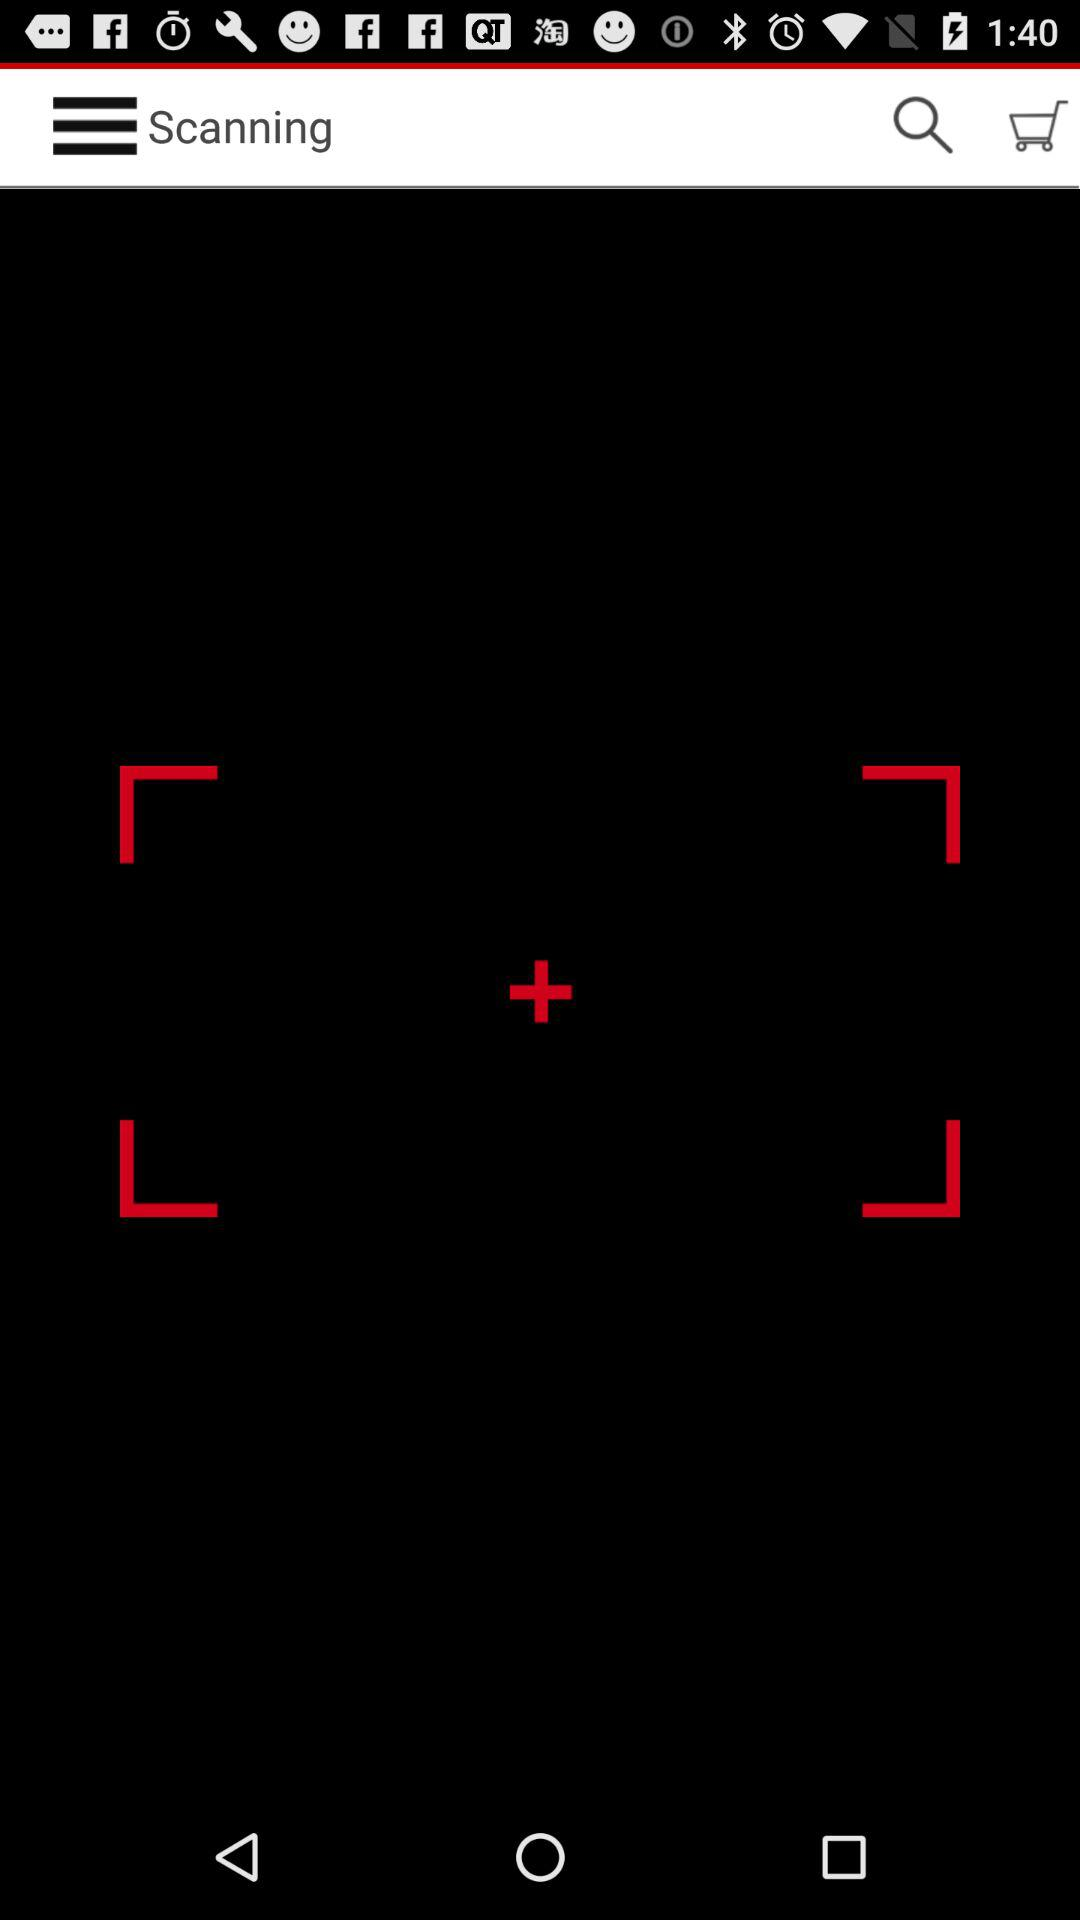Is there any item in the cart?
When the provided information is insufficient, respond with <no answer>. <no answer> 